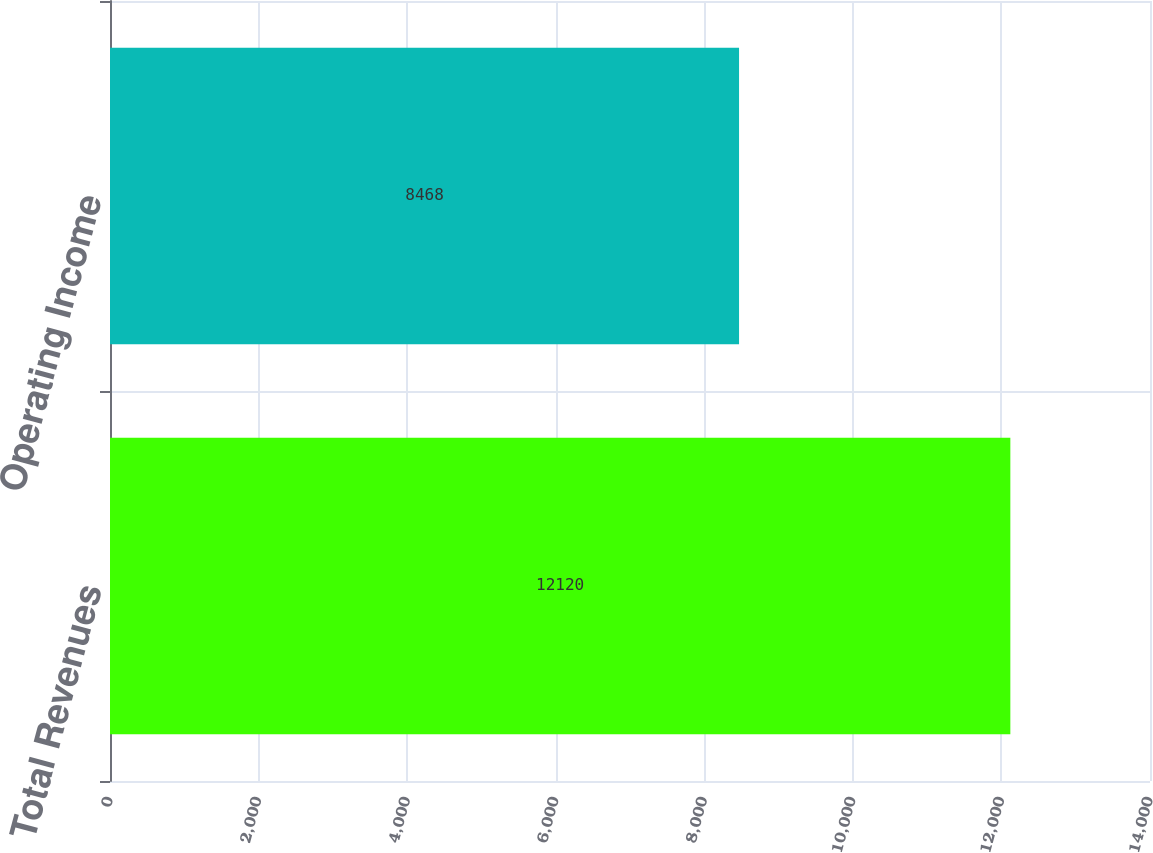<chart> <loc_0><loc_0><loc_500><loc_500><bar_chart><fcel>Total Revenues<fcel>Operating Income<nl><fcel>12120<fcel>8468<nl></chart> 